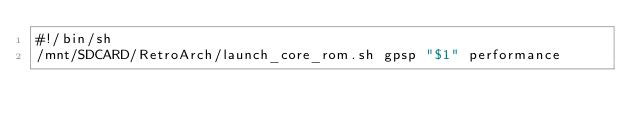<code> <loc_0><loc_0><loc_500><loc_500><_Bash_>#!/bin/sh
/mnt/SDCARD/RetroArch/launch_core_rom.sh gpsp "$1" performance</code> 